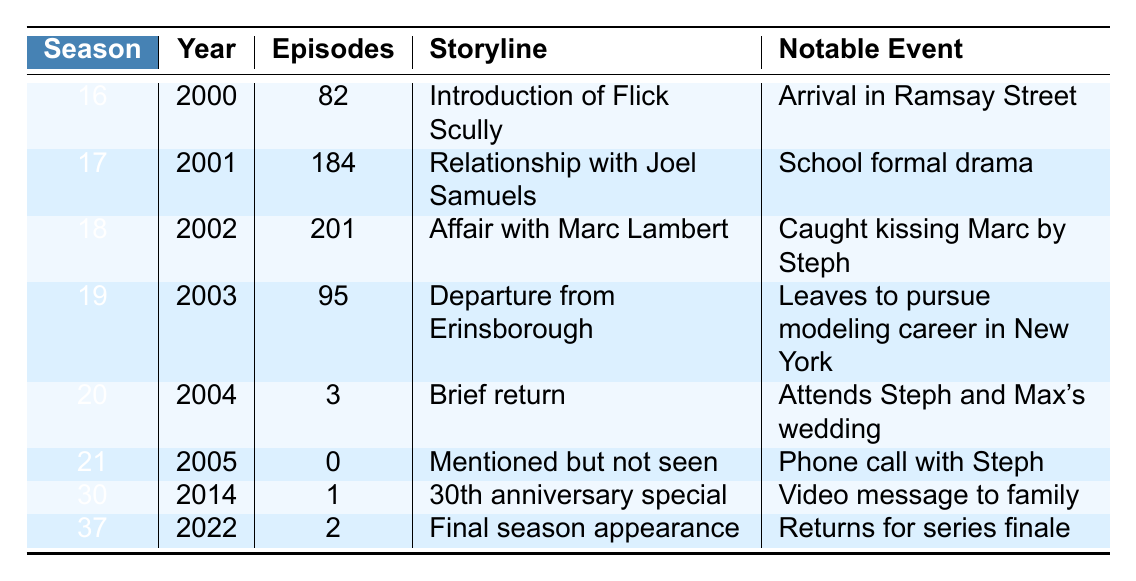What season did Flick Scully first appear in Neighbours? Flick Scully first appeared in Season 16 of Neighbours, as indicated in the table.
Answer: Season 16 How many episodes did Flick appear in during her relationship with Joel Samuels? According to the table, Flick appeared in 184 episodes during Season 17, which covers her relationship with Joel Samuels.
Answer: 184 episodes In which season did Flick Scully have her final appearance? The final appearance of Flick Scully was in Season 37, as noted in the last row of the table.
Answer: Season 37 What notable event occurred when Flick was caught kissing Marc Lambert? The notable event during her affair with Marc Lambert, as stated in the table, is that she was caught kissing him by Steph.
Answer: Caught kissing Marc by Steph How many episodes did Flick Scully appear in during her departure from Erinsborough? Flick Scully appeared in 95 episodes during Season 19, which is when she was depicted departing from Erinsborough.
Answer: 95 episodes What is the total number of episodes Flick appeared in from Seasons 16 to 19? The total number of episodes is calculated by summing 82 (Season 16) + 184 (Season 17) + 201 (Season 18) + 95 (Season 19) = 562.
Answer: 562 episodes Was Flick Scully seen in Season 21? The table indicates that Flick Scully was mentioned but not seen in Season 21.
Answer: No In which year did Flick appear in the 30th anniversary special? The table shows that Flick appeared in the 30th anniversary special during the year 2014, which is when Season 30 was aired.
Answer: 2014 What storyline did Flick follow in her brief return in Season 20? The storyline for her brief return in Season 20 was to attend Steph and Max's wedding, as noted in the table.
Answer: Attends Steph and Max's wedding How many more episodes did Flick appear in during Season 18 compared to Season 20? Flick appeared in 201 episodes in Season 18 and 3 episodes in Season 20. The difference is 201 - 3 = 198.
Answer: 198 episodes more 